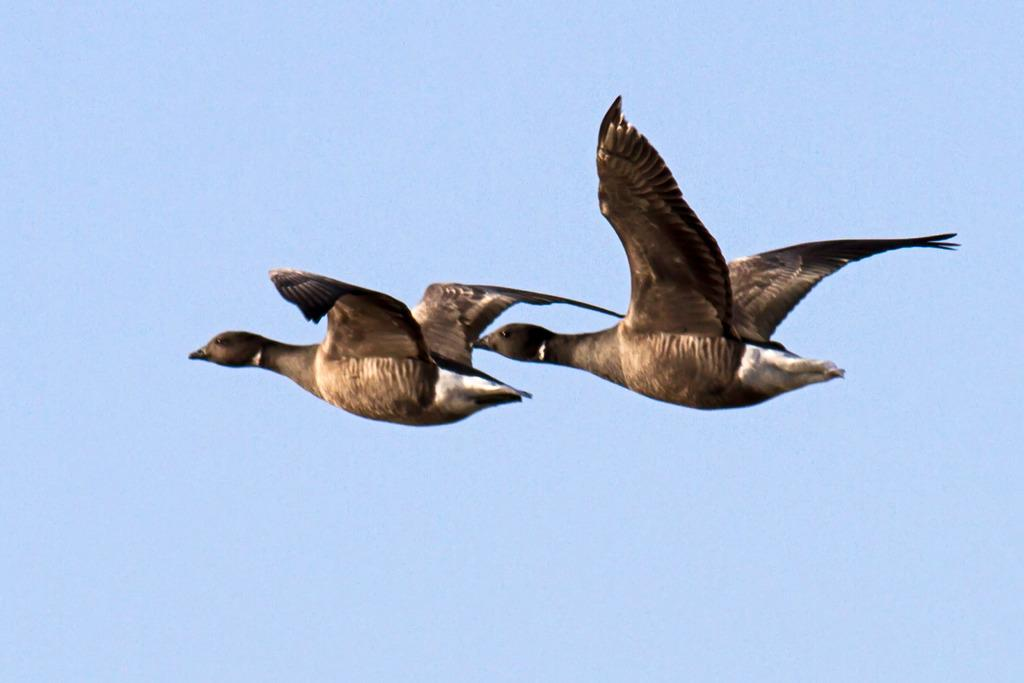How many birds are present in the image? There are two birds in the image. What are the birds doing in the image? The birds are flying in the sky. What book is the bird holding in its beak in the image? There is no book present in the image; the birds are flying without any objects in their beaks. 